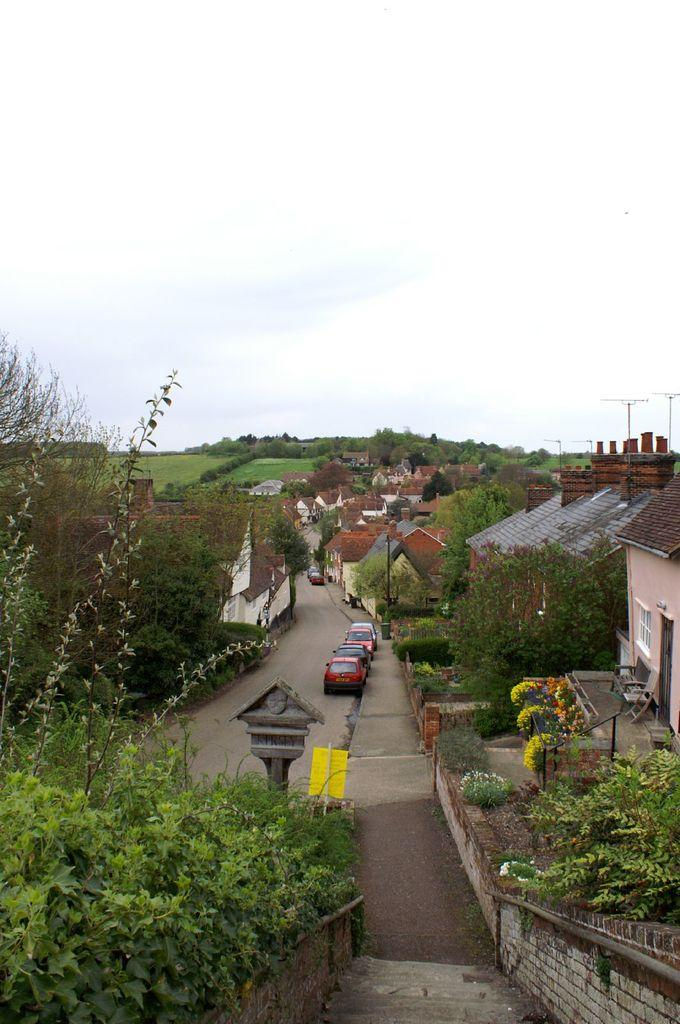What can be seen on the left side of the image? There are trees and houses on the left side of the image. What can be seen on the right side of the image? There are trees and houses on the right side of the image. What architectural feature is present in the image? There are steps in the image. What type of objects are visible in the image? There are vehicles in the image. What is visible in the background of the image? There are houses, vehicles, and trees in the background of the image. What can be seen at the top of the image? The sky is visible at the top of the image. What type of cork can be seen in the image? There is no cork present in the image. How does the beam of light affect the houses in the image? There is no beam of light present in the image. 